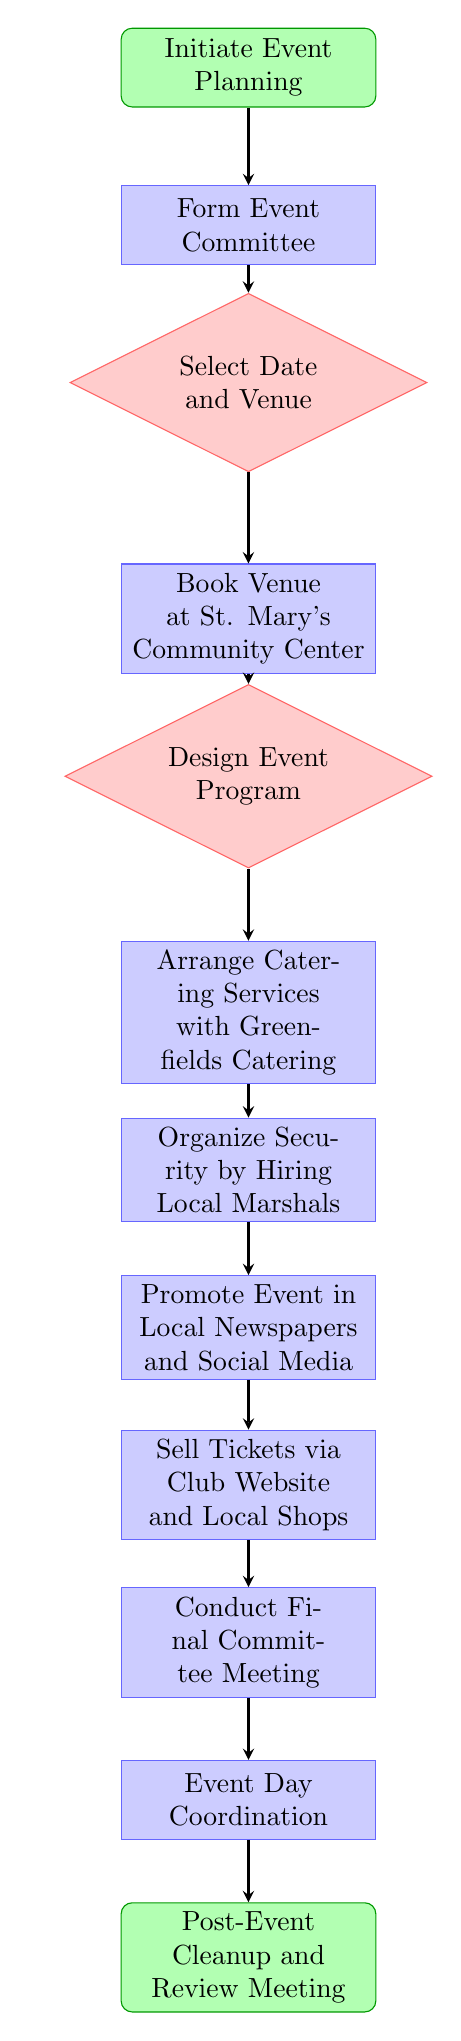What is the starting point of the event planning process? The diagram indicates that the starting point of the event planning process is "Initiate Event Planning," which is the first node in the flow chart.
Answer: Initiate Event Planning What is the decision made after forming the event committee? After forming the event committee, the next step in the process is to make a decision regarding the "Select Date and Venue," which follows directly from the committee formation.
Answer: Select Date and Venue How many processes are involved in the event planning process? By reviewing the flow chart, we can count the number of process nodes. There are five process nodes: "Form Event Committee," "Book Venue at St. Mary's Community Center," "Arrange Catering Services with Greenfields Catering," "Organize Security by Hiring Local Marshals," and "Promote Event in Local Newspapers and Social Media." Thus, there are five processes in total.
Answer: 5 What is the final step in the event planning process? The final step indicated in the diagram is "Post-Event Cleanup and Review Meeting," which occurs after "Event Day Coordination."
Answer: Post-Event Cleanup and Review Meeting What node follows the decision about designing the event program? The decision about designing the event program leads to the process of "Arrange Catering Services with Greenfields Catering," as indicated in the flow from the program decision to the catering arrangement.
Answer: Arrange Catering Services with Greenfields Catering How does event promotion occur in the planning process? The flow chart indicates that the event promotion occurs through the process node "Promote Event in Local Newspapers and Social Media," which follows the security organization step.
Answer: Promote Event in Local Newspapers and Social Media 